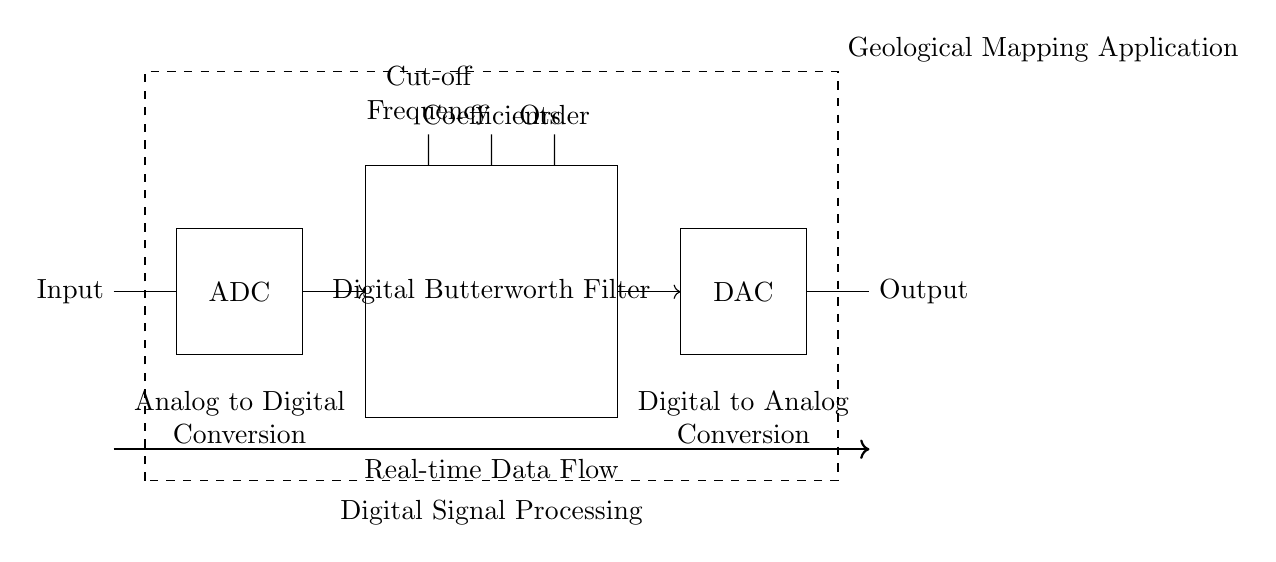What is the main function of the ADC in this circuit? The Analog to Digital Converter (ADC) in the circuit is responsible for converting the incoming analog signals from the geological data into digital signals for processing.
Answer: Converting analog signals What does the Digital Butterworth Filter do? The Digital Butterworth Filter processes the incoming digital signals by applying a specific filtering technique to remove unwanted frequencies and preserve the desired signal qualities for geological mapping applications.
Answer: Signal filtering What parameter is shown alongside the Digital Butterworth Filter? The parameters indicated are the coefficients, cut-off frequency, and order, which are crucial for defining the filter's characteristics and performance in digital signal processing.
Answer: Coefficients, cut-off frequency, order Which component converts digital signals back into analog form? The Digital to Analog Converter (DAC) converts the filtered digital signals from the Digital Butterworth Filter back into analog signals for output.
Answer: Digital to Analog Converter What is the purpose of the dashed rectangle in the diagram? The dashed rectangle represents the overall Geological Mapping Application, indicating that the components within the rectangle work together specifically for that application, highlighting the purpose of the circuit.
Answer: Geological Mapping Application How does the signal flow through the circuit? The signal flow starts from the input, going through the ADC, then to the Digital Butterworth Filter, followed by the DAC, and finally producing the output. The arrows indicate the direction of this flow.
Answer: Input to output through ADC, filter, DAC What aspect of the filter can be adjusted for different applications? The cut-off frequency and order can be adjusted to tailor the filter's performance, allowing it to be optimized for a variety of geological mapping data requirements.
Answer: Cut-off frequency and order 